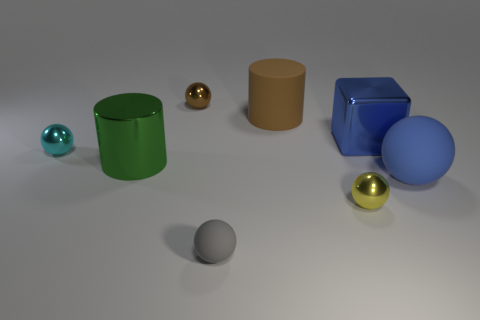Subtract all small brown metallic spheres. How many spheres are left? 4 Add 2 tiny blue rubber spheres. How many objects exist? 10 Subtract all brown balls. How many balls are left? 4 Subtract all balls. How many objects are left? 3 Subtract 3 balls. How many balls are left? 2 Subtract all cyan spheres. Subtract all green cylinders. How many spheres are left? 4 Subtract all blue cylinders. How many brown spheres are left? 1 Subtract all red shiny blocks. Subtract all gray objects. How many objects are left? 7 Add 5 matte things. How many matte things are left? 8 Add 3 blue shiny blocks. How many blue shiny blocks exist? 4 